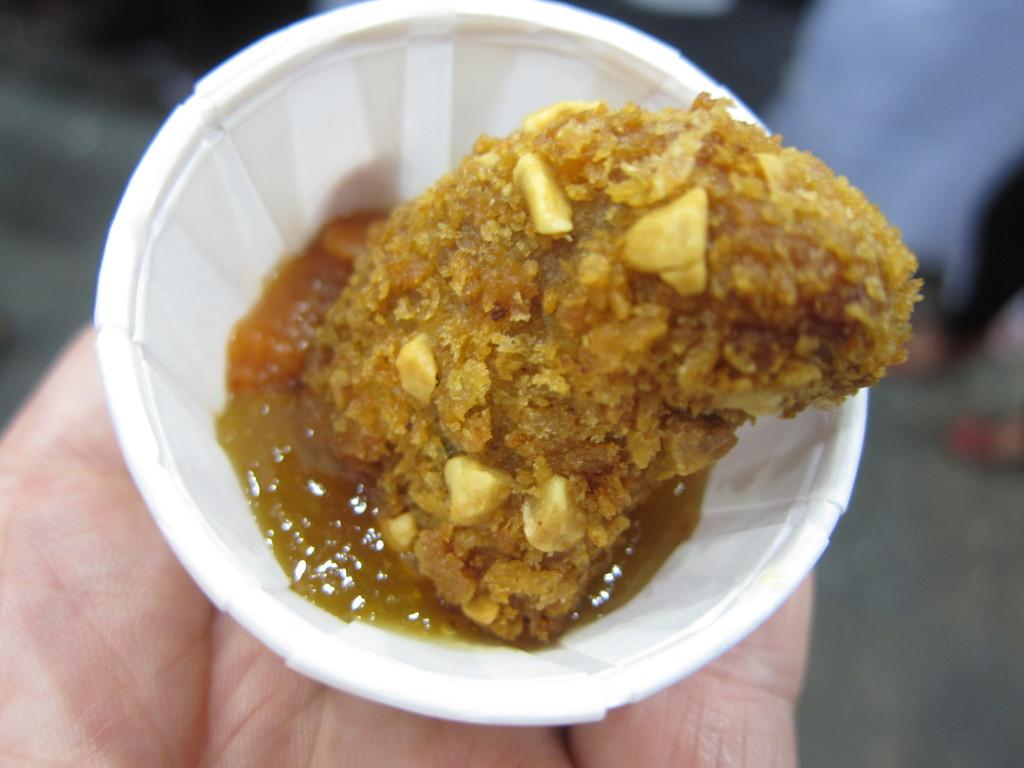What can be seen in the image related to a person's hand? There is a person's hand in the image. What is the hand holding? The hand is holding a cup. What is inside the cup that the hand is holding? The cup contains a food item. What type of doctor can be seen examining the snails in the image? There are no doctors or snails present in the image; it only features a person's hand holding a cup with a food item. 